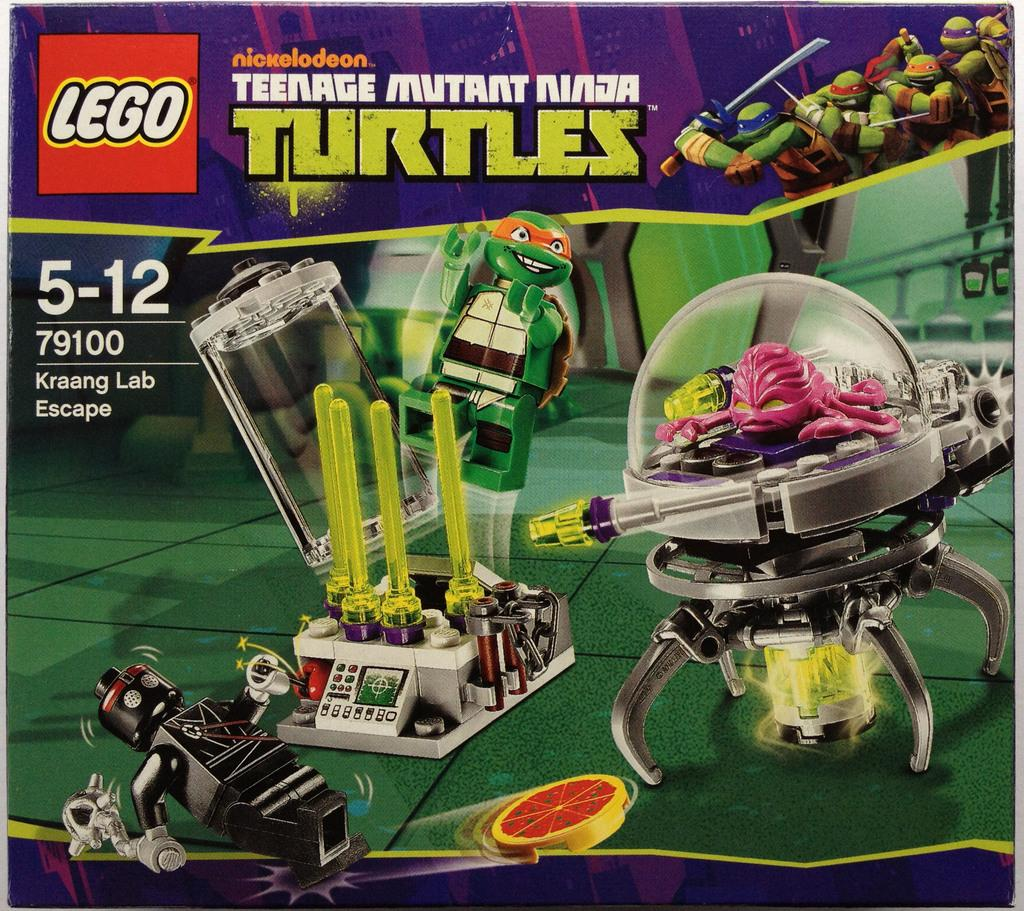<image>
Create a compact narrative representing the image presented. A box of Teenage Mutant Ninja Turtle Legos. 